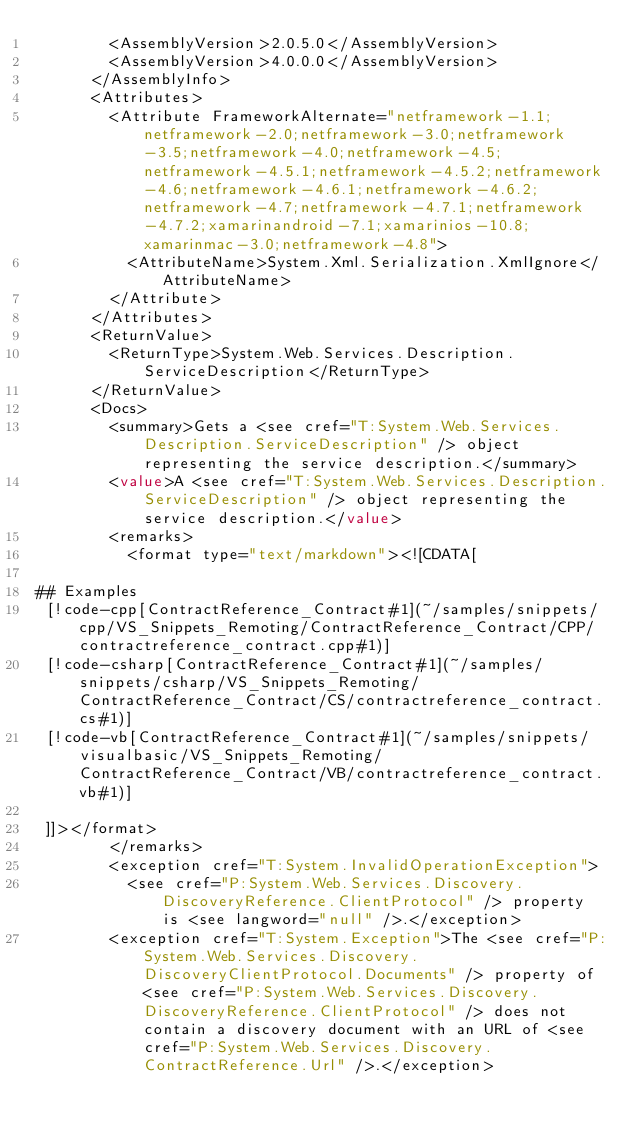Convert code to text. <code><loc_0><loc_0><loc_500><loc_500><_XML_>        <AssemblyVersion>2.0.5.0</AssemblyVersion>
        <AssemblyVersion>4.0.0.0</AssemblyVersion>
      </AssemblyInfo>
      <Attributes>
        <Attribute FrameworkAlternate="netframework-1.1;netframework-2.0;netframework-3.0;netframework-3.5;netframework-4.0;netframework-4.5;netframework-4.5.1;netframework-4.5.2;netframework-4.6;netframework-4.6.1;netframework-4.6.2;netframework-4.7;netframework-4.7.1;netframework-4.7.2;xamarinandroid-7.1;xamarinios-10.8;xamarinmac-3.0;netframework-4.8">
          <AttributeName>System.Xml.Serialization.XmlIgnore</AttributeName>
        </Attribute>
      </Attributes>
      <ReturnValue>
        <ReturnType>System.Web.Services.Description.ServiceDescription</ReturnType>
      </ReturnValue>
      <Docs>
        <summary>Gets a <see cref="T:System.Web.Services.Description.ServiceDescription" /> object representing the service description.</summary>
        <value>A <see cref="T:System.Web.Services.Description.ServiceDescription" /> object representing the service description.</value>
        <remarks>
          <format type="text/markdown"><![CDATA[  
  
## Examples  
 [!code-cpp[ContractReference_Contract#1](~/samples/snippets/cpp/VS_Snippets_Remoting/ContractReference_Contract/CPP/contractreference_contract.cpp#1)]
 [!code-csharp[ContractReference_Contract#1](~/samples/snippets/csharp/VS_Snippets_Remoting/ContractReference_Contract/CS/contractreference_contract.cs#1)]
 [!code-vb[ContractReference_Contract#1](~/samples/snippets/visualbasic/VS_Snippets_Remoting/ContractReference_Contract/VB/contractreference_contract.vb#1)]  
  
 ]]></format>
        </remarks>
        <exception cref="T:System.InvalidOperationException">
          <see cref="P:System.Web.Services.Discovery.DiscoveryReference.ClientProtocol" /> property is <see langword="null" />.</exception>
        <exception cref="T:System.Exception">The <see cref="P:System.Web.Services.Discovery.DiscoveryClientProtocol.Documents" /> property of <see cref="P:System.Web.Services.Discovery.DiscoveryReference.ClientProtocol" /> does not contain a discovery document with an URL of <see cref="P:System.Web.Services.Discovery.ContractReference.Url" />.</exception></code> 